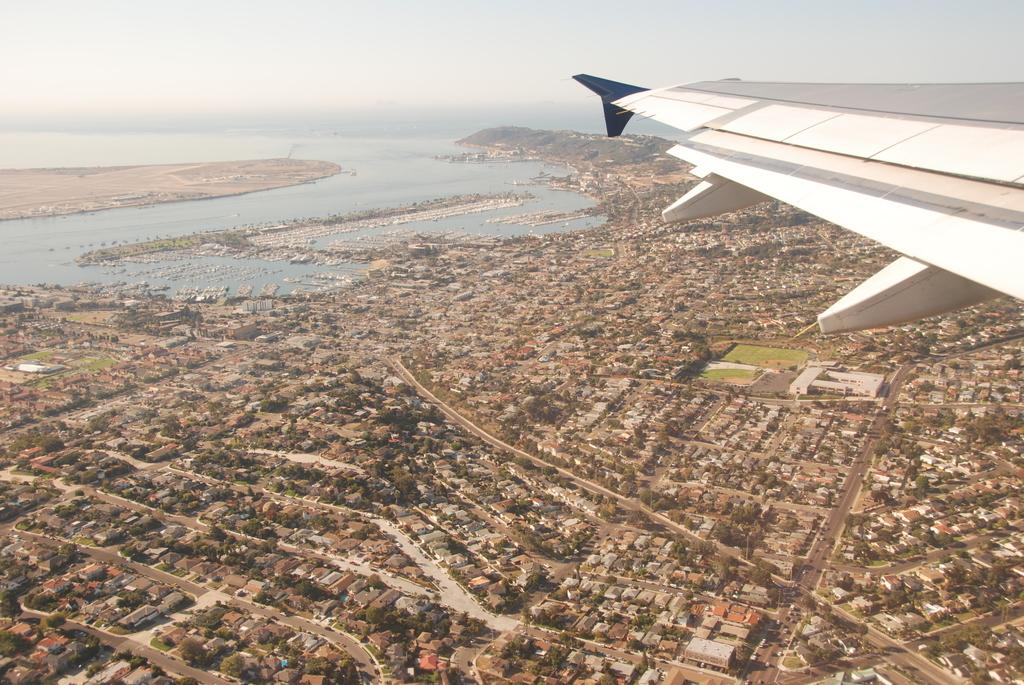What type of structures can be seen in the image? There are buildings in the image. What natural elements are present in the image? There are trees and a surface of water visible in the image. Can you describe the wing in the image? A wing of a plane is present in the image. What part of the natural environment is visible in the image? The sky is visible in the image. Are there any giants playing drums in the image? There are no giants or drums present in the image. What stage of development is the city in, as seen in the image? The image does not provide information about the development stage of the city. 